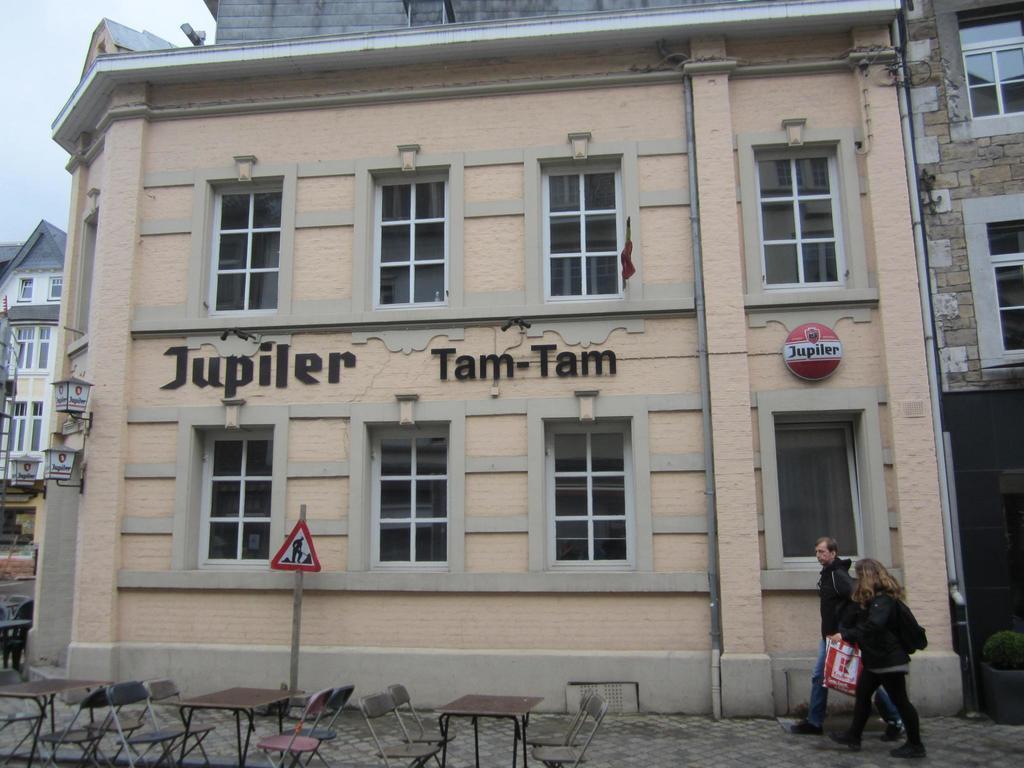Please provide a concise description of this image. In this image we can see some buildings and there are two people walking on a sidewalk and one among the is holding a cover. We can see some tables and chairs and there is a pole with a signboard. 